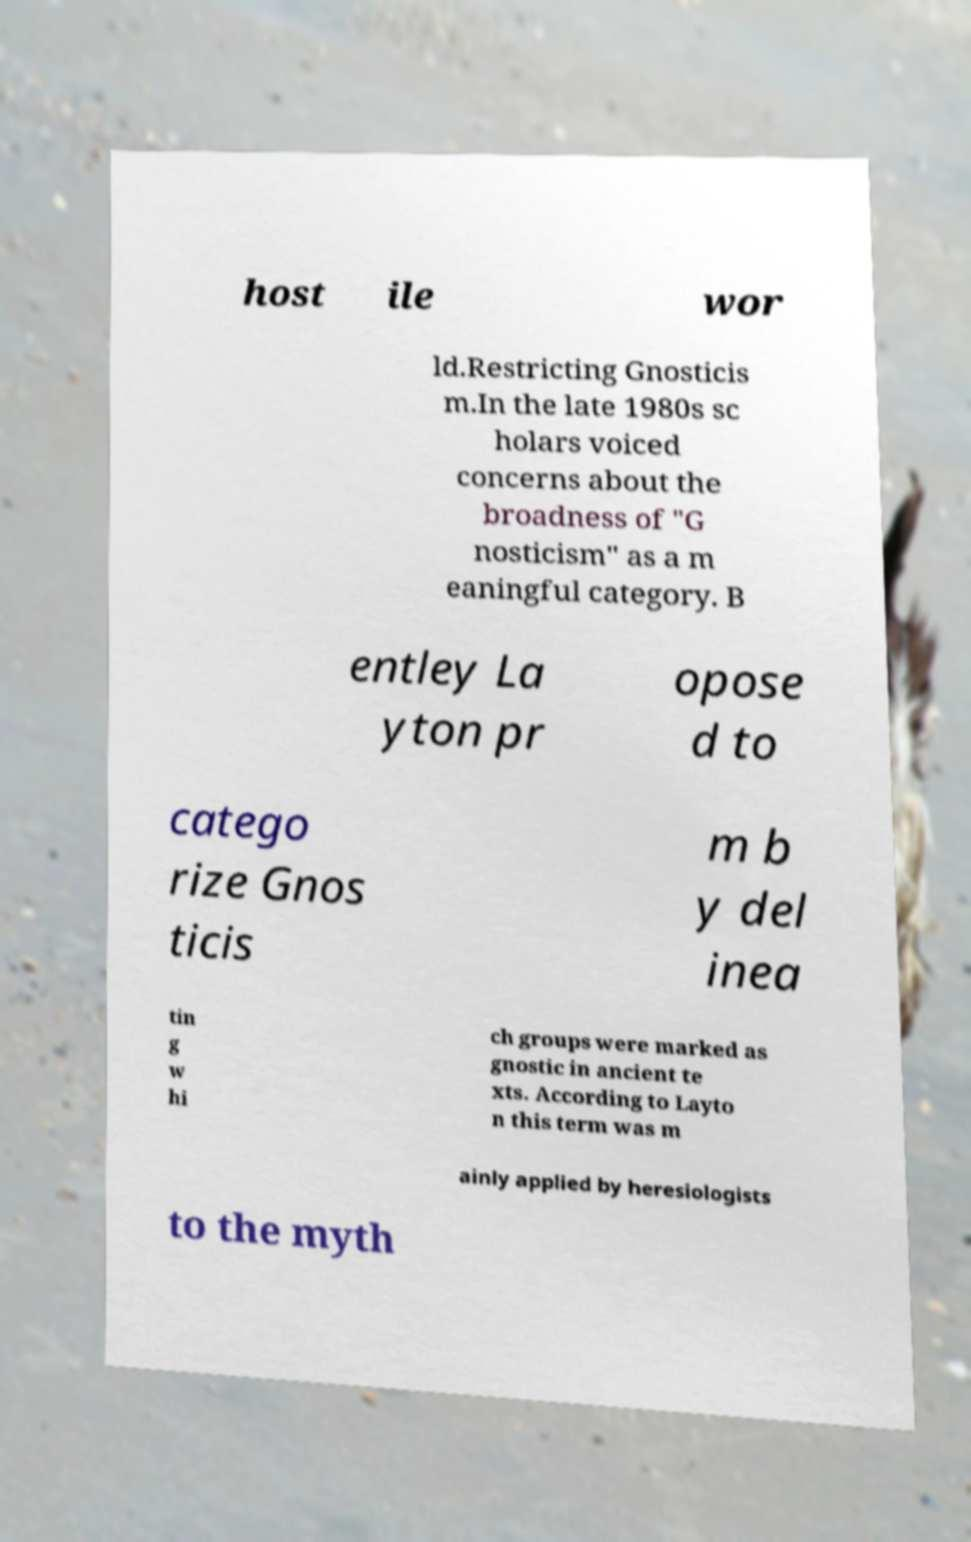Could you extract and type out the text from this image? host ile wor ld.Restricting Gnosticis m.In the late 1980s sc holars voiced concerns about the broadness of "G nosticism" as a m eaningful category. B entley La yton pr opose d to catego rize Gnos ticis m b y del inea tin g w hi ch groups were marked as gnostic in ancient te xts. According to Layto n this term was m ainly applied by heresiologists to the myth 